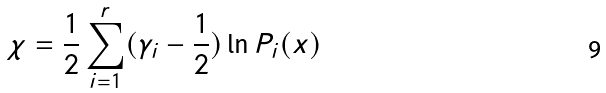<formula> <loc_0><loc_0><loc_500><loc_500>\chi = \frac { 1 } { 2 } \sum ^ { r } _ { i = 1 } ( \gamma _ { i } - \frac { 1 } { 2 } ) \ln P _ { i } ( x )</formula> 